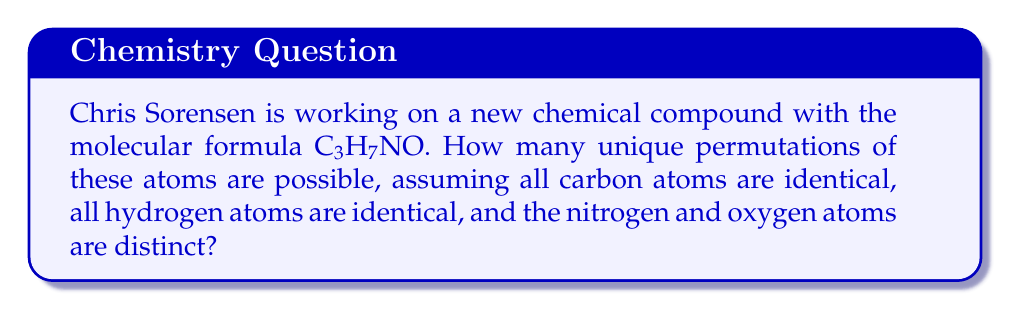Help me with this question. Let's approach this step-by-step:

1) First, we need to count the total number of atoms:
   3 Carbon (C) atoms
   7 Hydrogen (H) atoms
   1 Nitrogen (N) atom
   1 Oxygen (O) atom
   Total: 12 atoms

2) If all atoms were distinct, we would have 12! permutations. However, we need to account for the identical C and H atoms.

3) The formula for this type of permutation with repeated elements is:

   $$ \frac{n!}{n_1! \cdot n_2! \cdot ... \cdot n_k!} $$

   Where n is the total number of elements, and $n_1, n_2, ..., n_k$ are the numbers of each repeated element.

4) In our case:
   $n = 12$ (total atoms)
   $n_1 = 3$ (Carbon atoms)
   $n_2 = 7$ (Hydrogen atoms)

5) Plugging into the formula:

   $$ \frac{12!}{3! \cdot 7!} $$

6) Calculating:
   $$ \frac{12!}{3! \cdot 7!} = \frac{479,001,600}{6 \cdot 5,040} = 15,840 $$

Therefore, there are 15,840 unique permutations of the atoms in this compound.
Answer: 15,840 